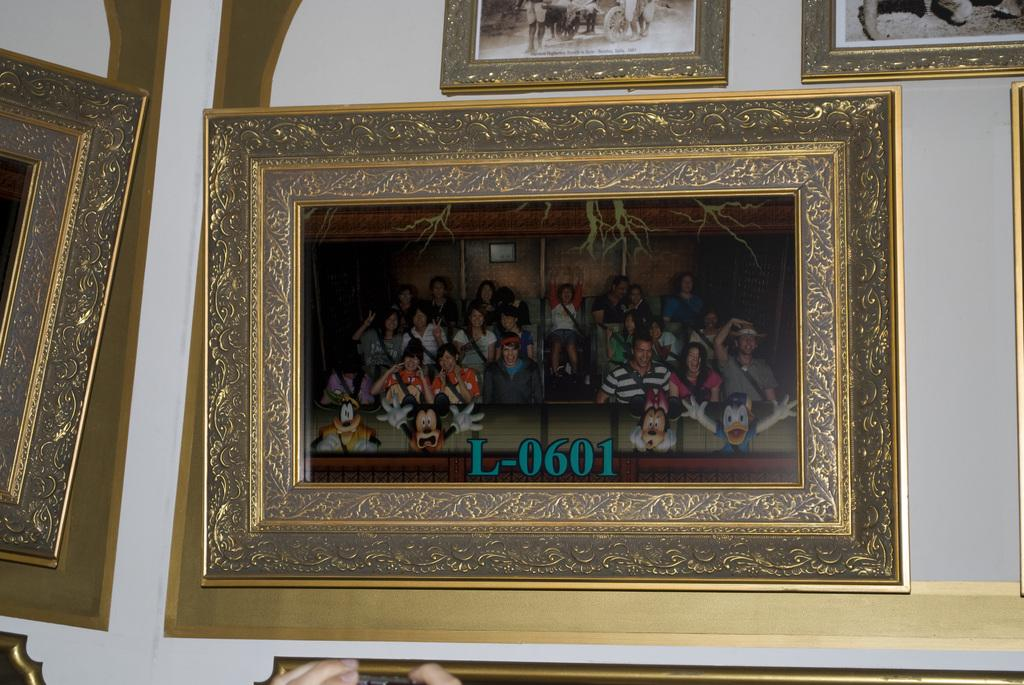<image>
Summarize the visual content of the image. A framed photographed is labelled L-0601 to identify it. 